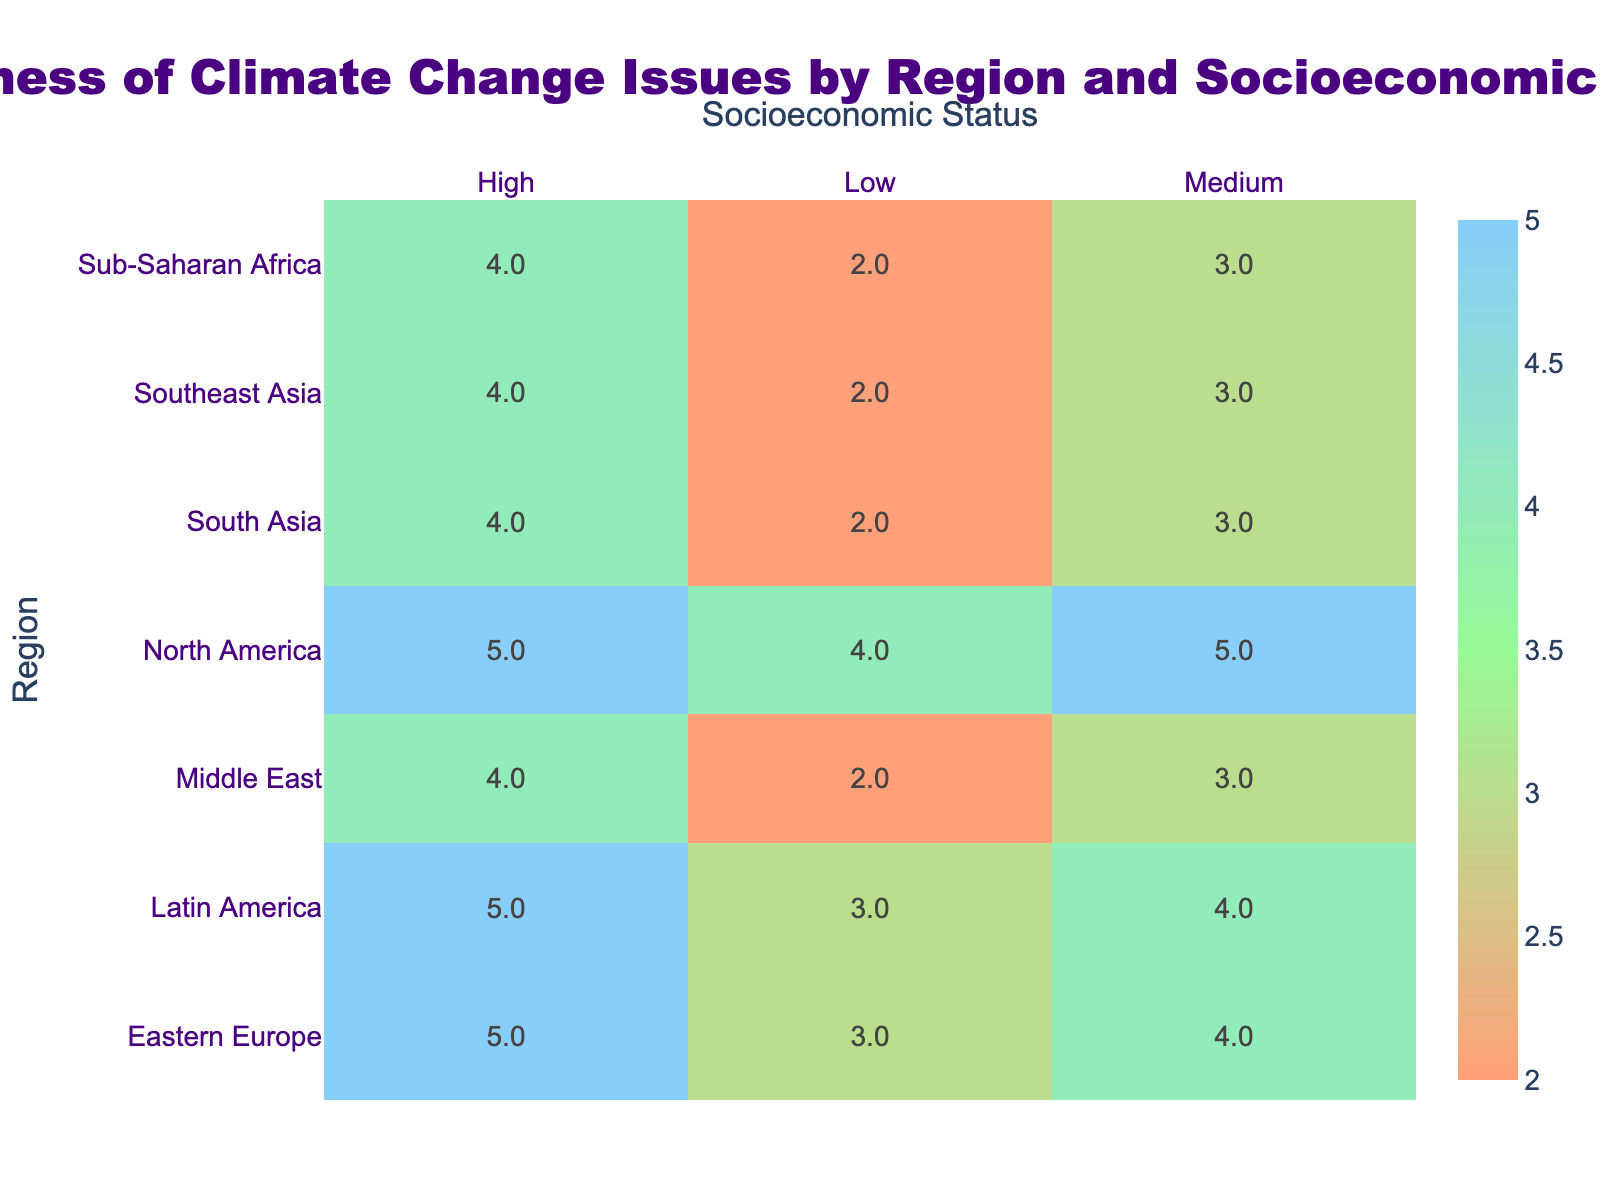What is the awareness level for the High socioeconomic status in Latin America? According to the table, the awareness level for the High socioeconomic status in Latin America is 5.
Answer: 5 What is the awareness level for the Low socioeconomic status in Sub-Saharan Africa? The table indicates that the awareness level for the Low socioeconomic status in Sub-Saharan Africa is 2.
Answer: 2 Is the awareness level higher for the High or Medium socioeconomic status in Eastern Europe? The awareness level for the High socioeconomic status in Eastern Europe is 5, while for the Medium socioeconomic status, it is 4. Therefore, the High socioeconomic status has a higher awareness level.
Answer: Yes What is the average awareness level across all regions for the Low socioeconomic status? To calculate the average for the Low socioeconomic status, we sum the awareness levels: (2 + 2 + 3 + 3 + 4 + 2) = 16. There are 6 data points, so the average is 16/6 = approximately 2.67.
Answer: Approximately 2.67 Which region has the highest awareness level for the Medium socioeconomic status? The Medium socioeconomic status awareness levels are as follows: Sub-Saharan Africa (3), Southeast Asia (3), Latin America (4), Eastern Europe (4), North America (5), Middle East (3), South Asia (3). North America has the highest awareness level at 5.
Answer: North America What is the difference in awareness levels between the High socioeconomic status in North America and that in Middle East? The awareness level for the High socioeconomic status in North America is 5, while in the Middle East, it is 4. Hence, the difference is 5 - 4 = 1.
Answer: 1 Is the awareness level for the Low socioeconomic status in Southeast Asia higher than the awareness level for the Medium socioeconomic status in South Asia? The awareness level for Low socioeconomic status in Southeast Asia is 2, and for Medium socioeconomic status in South Asia, it is also 3. Thus, the awareness level for the Low in Southeast Asia is not higher.
Answer: No What is the total awareness level for the High socioeconomic status summed across all regions? Summing the High socioeconomic status awareness levels: (4 + 4 + 5 + 5 + 4 + 4) = 26.
Answer: 26 